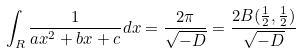<formula> <loc_0><loc_0><loc_500><loc_500>\int _ { R } \frac { 1 } { a x ^ { 2 } + b x + c } d x = \frac { 2 \pi } { \sqrt { - D } } = \frac { 2 B ( \frac { 1 } { 2 } , \frac { 1 } { 2 } ) } { \sqrt { - D } }</formula> 